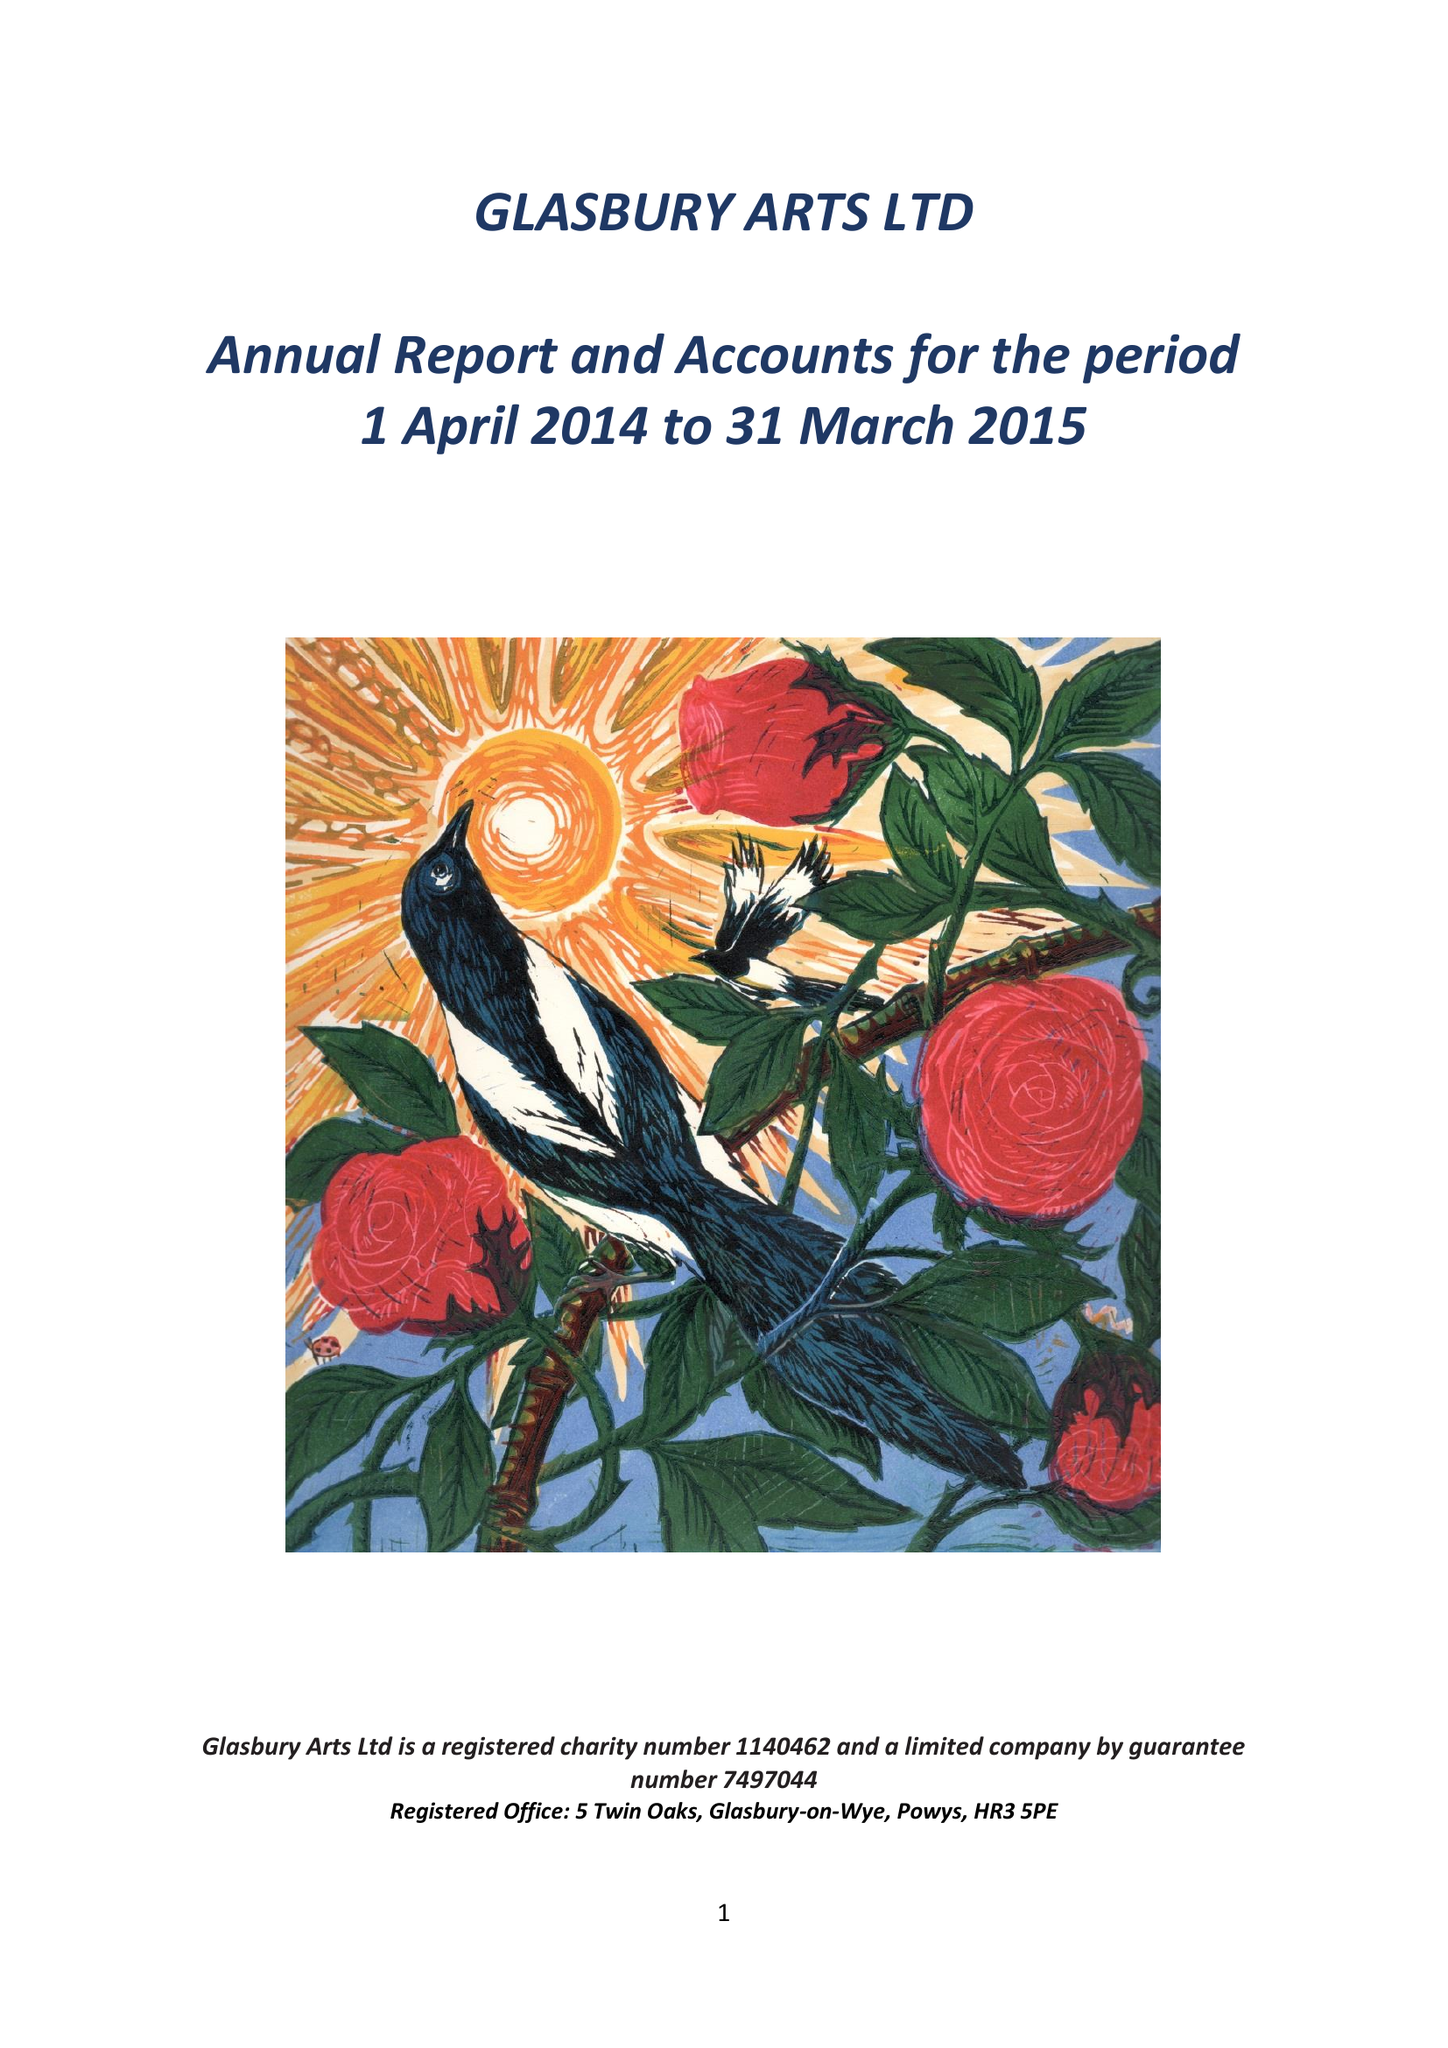What is the value for the address__post_town?
Answer the question using a single word or phrase. HEREFORD 